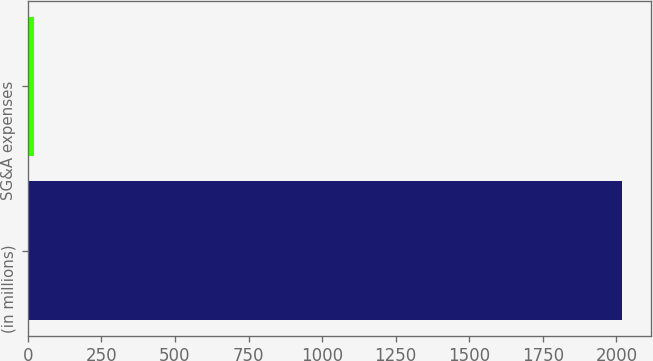Convert chart. <chart><loc_0><loc_0><loc_500><loc_500><bar_chart><fcel>(in millions)<fcel>SG&A expenses<nl><fcel>2018<fcel>22<nl></chart> 